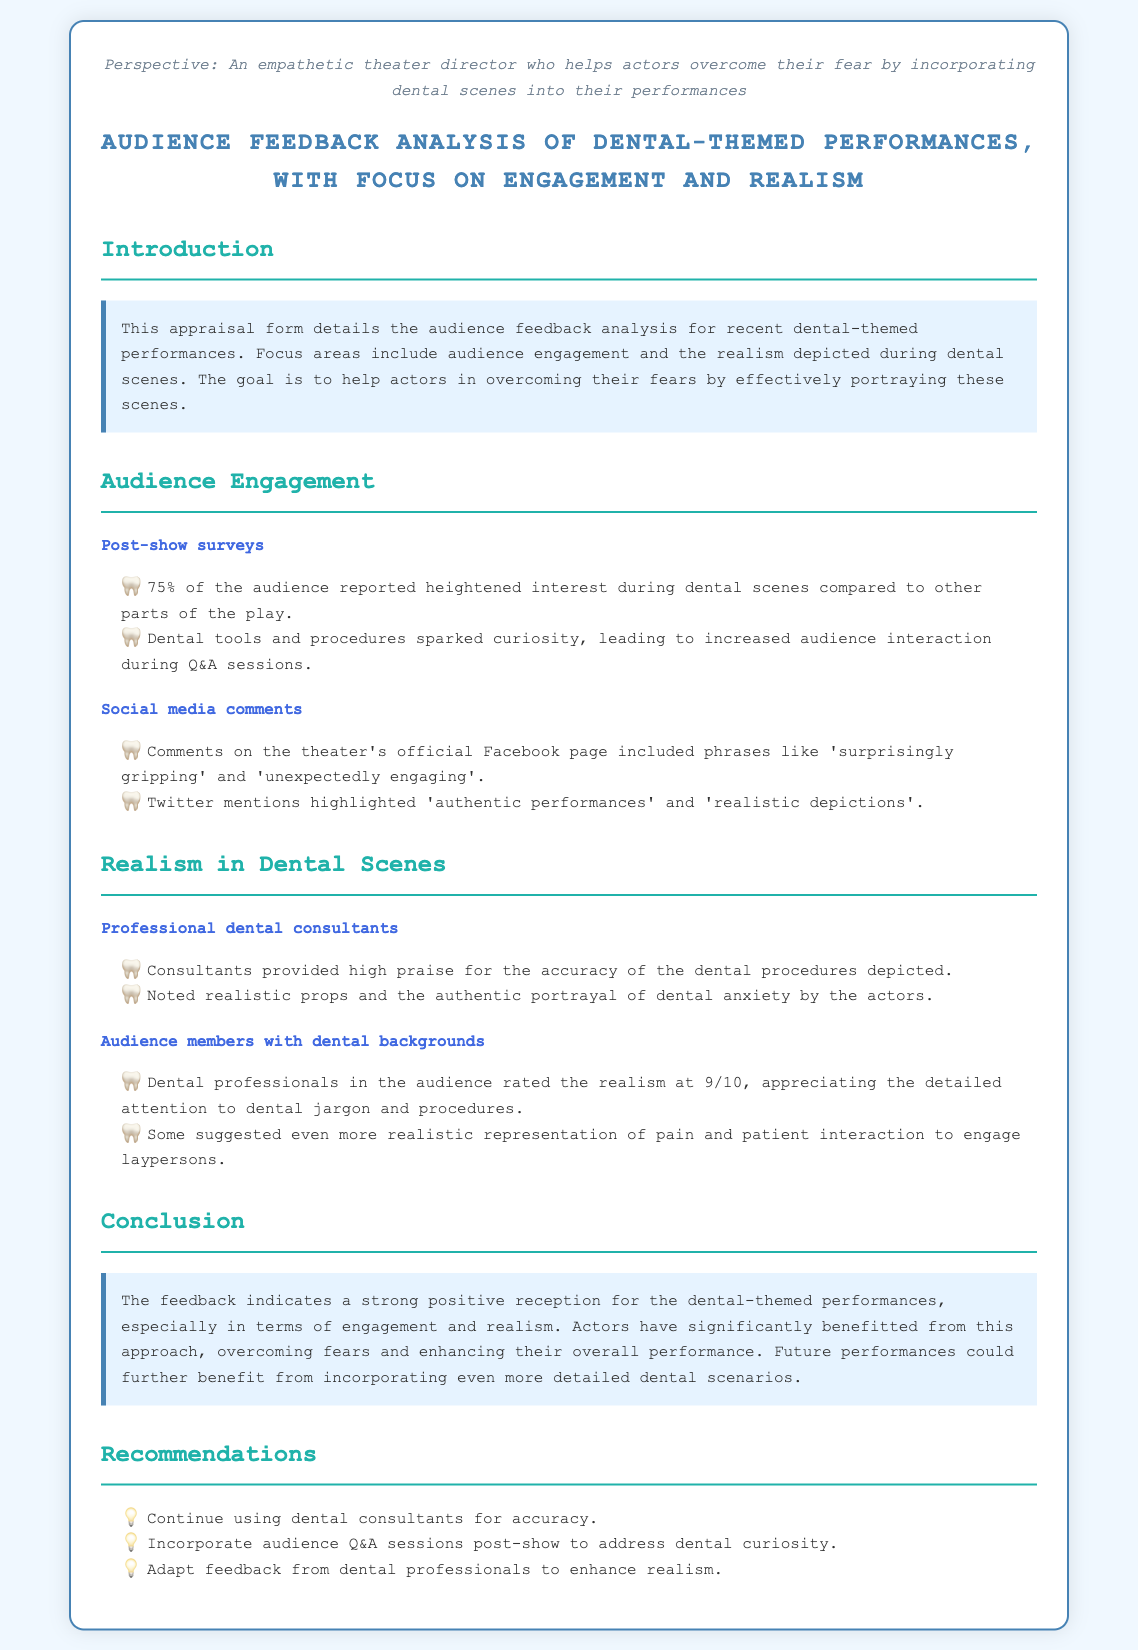What percentage of the audience reported heightened interest during dental scenes? The document states that 75% of the audience reported heightened interest during dental scenes compared to other parts of the play.
Answer: 75% What did dental professionals rate the realism of the scenes? Audience members with dental backgrounds rated the realism at 9/10, appreciating the detailed attention to dental jargon and procedures.
Answer: 9/10 What is one phrase used in social media comments about the performances? The document mentions phrases like 'surprisingly gripping' and 'unexpectedly engaging' used in comments on the theater's official Facebook page.
Answer: surprisingly gripping What did professional dental consultants praise about the performances? Consultants provided high praise for the accuracy of the dental procedures depicted in the performances.
Answer: accuracy What is one recommendation for improving future performances? The document recommends continuing to use dental consultants for accuracy.
Answer: continue using dental consultants 